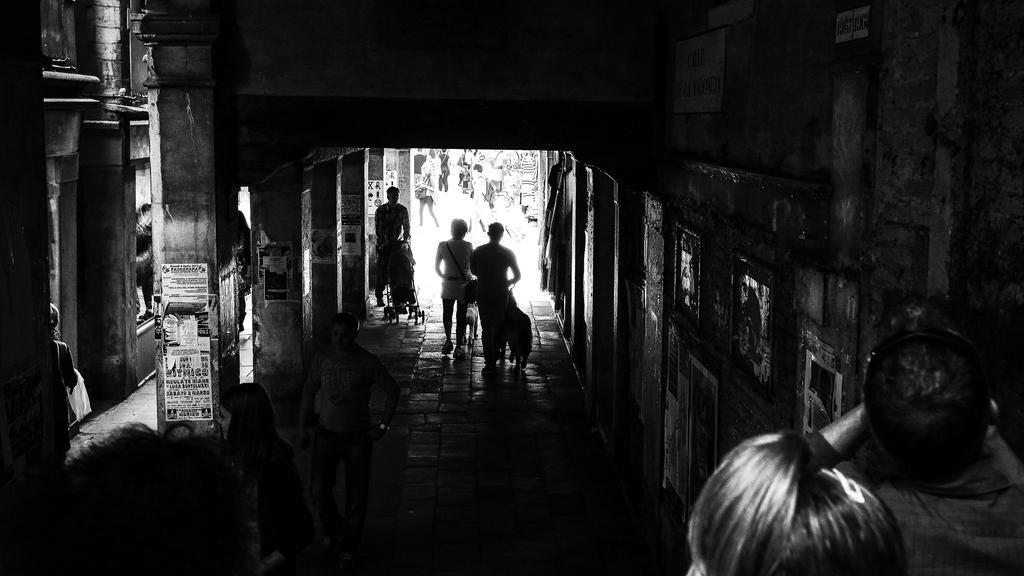Please provide a concise description of this image. In this image there are a few people walking in a building. 